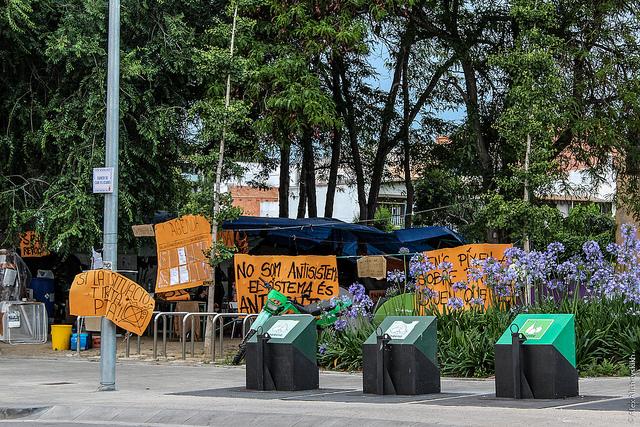What three objects have graffiti?
Short answer required. Signs. What mode of transportation can be seen?
Write a very short answer. None. Is there a protest?
Write a very short answer. Yes. What language is on the signs?
Answer briefly. Spanish. 